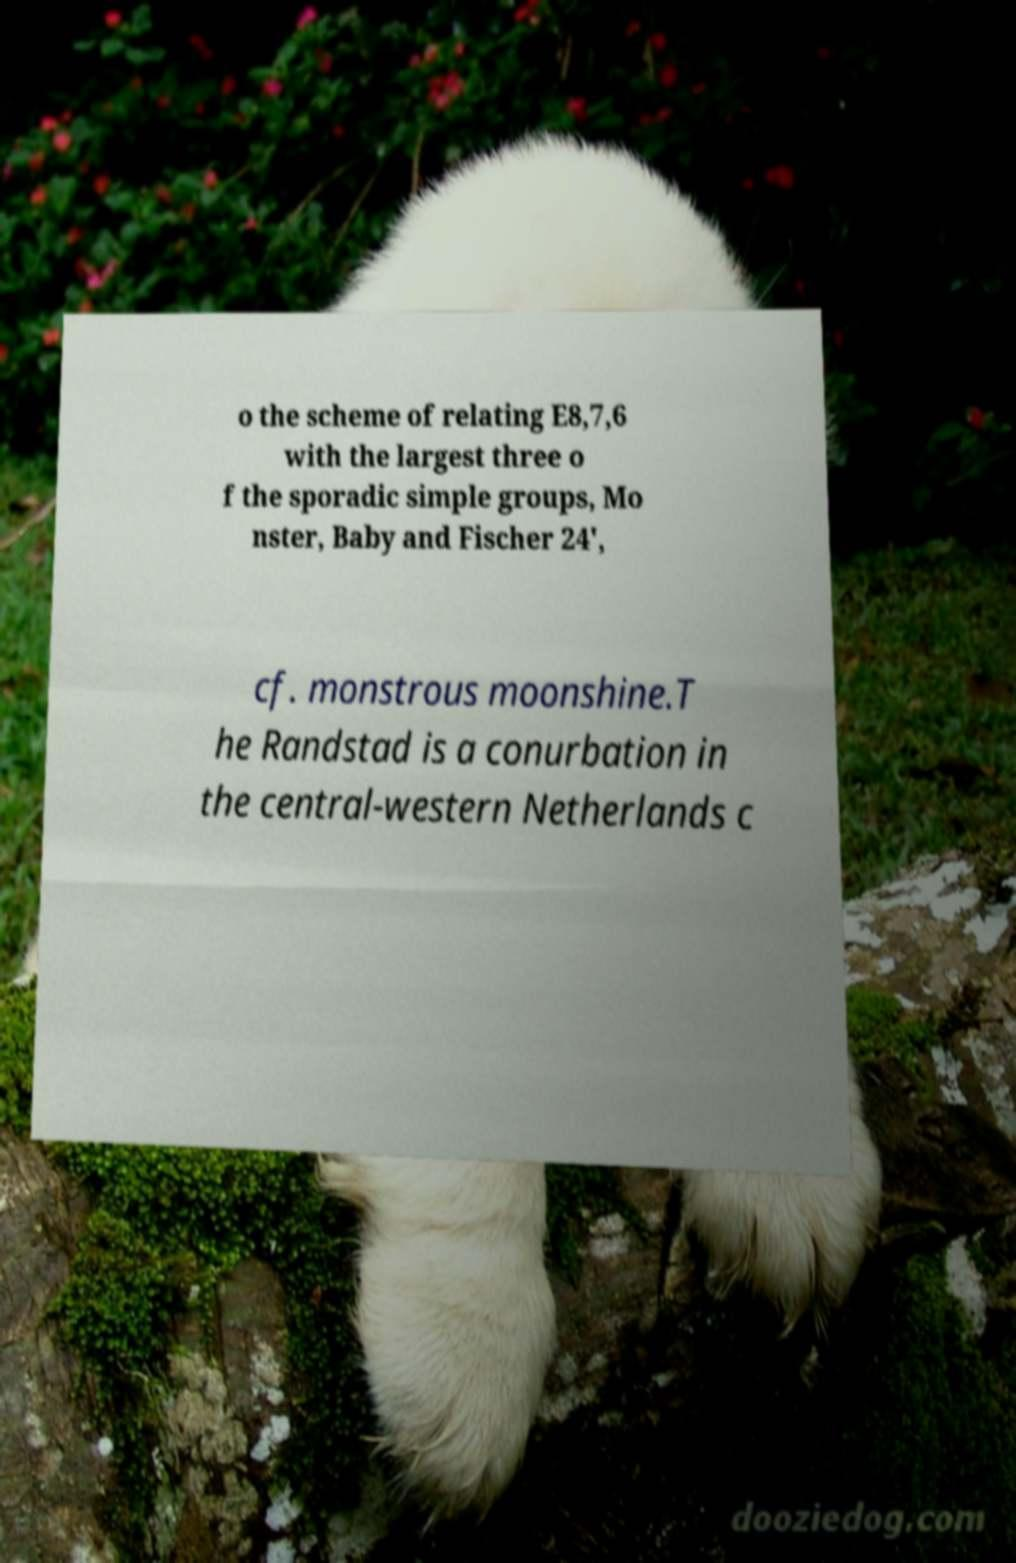I need the written content from this picture converted into text. Can you do that? o the scheme of relating E8,7,6 with the largest three o f the sporadic simple groups, Mo nster, Baby and Fischer 24', cf. monstrous moonshine.T he Randstad is a conurbation in the central-western Netherlands c 